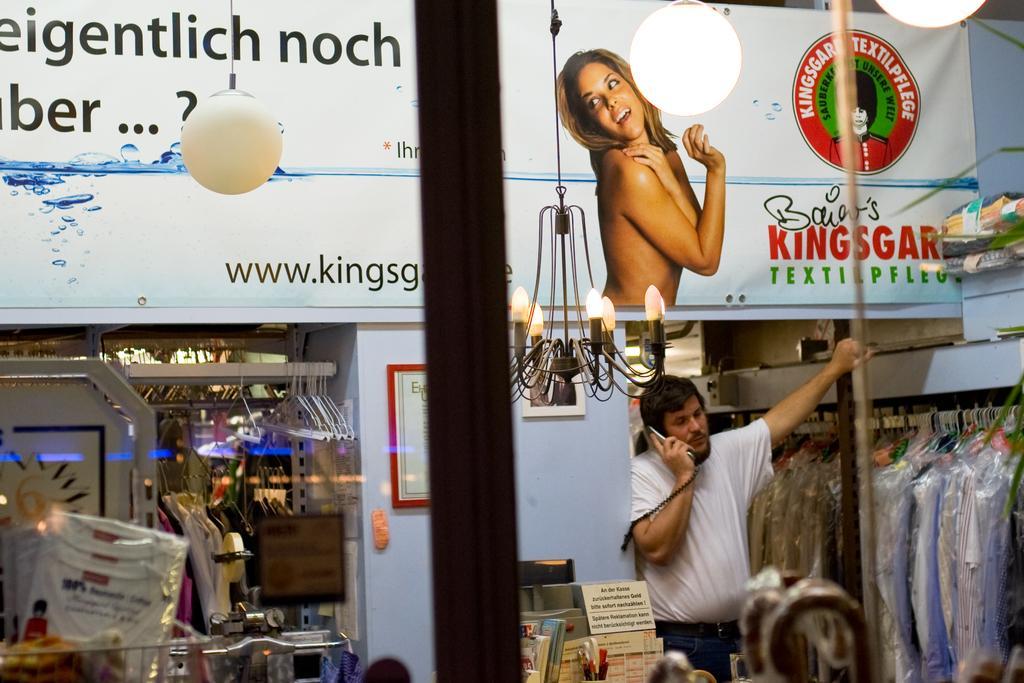Can you describe this image briefly? In this image we can see a person standing and holding a phone and the place looks like a store with some objects and there is a wall with photo frames and we can see the chandelier. There is a board with some text and a picture of a person. 